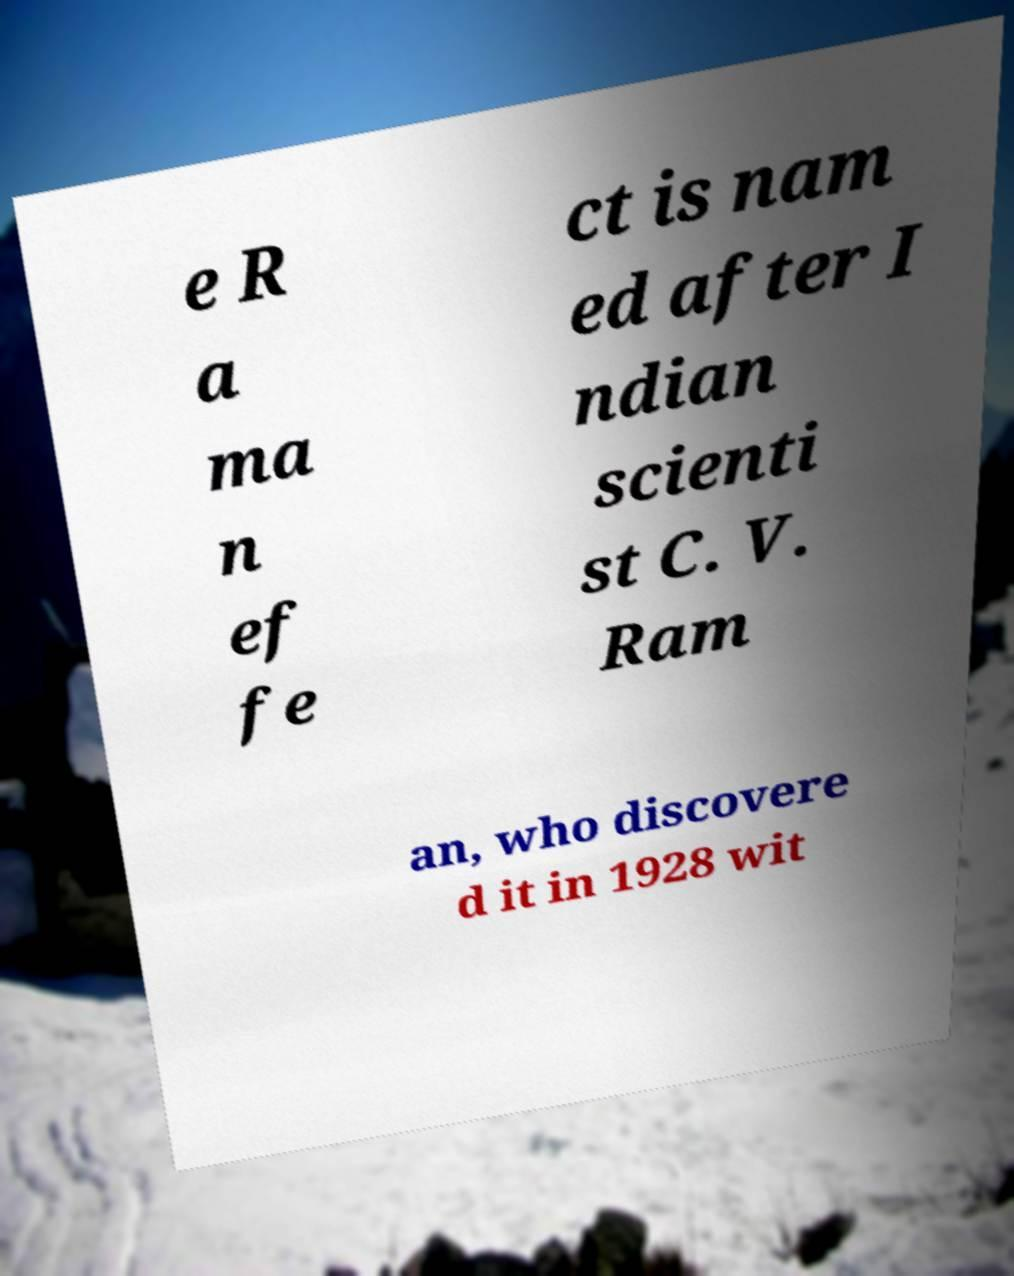I need the written content from this picture converted into text. Can you do that? e R a ma n ef fe ct is nam ed after I ndian scienti st C. V. Ram an, who discovere d it in 1928 wit 